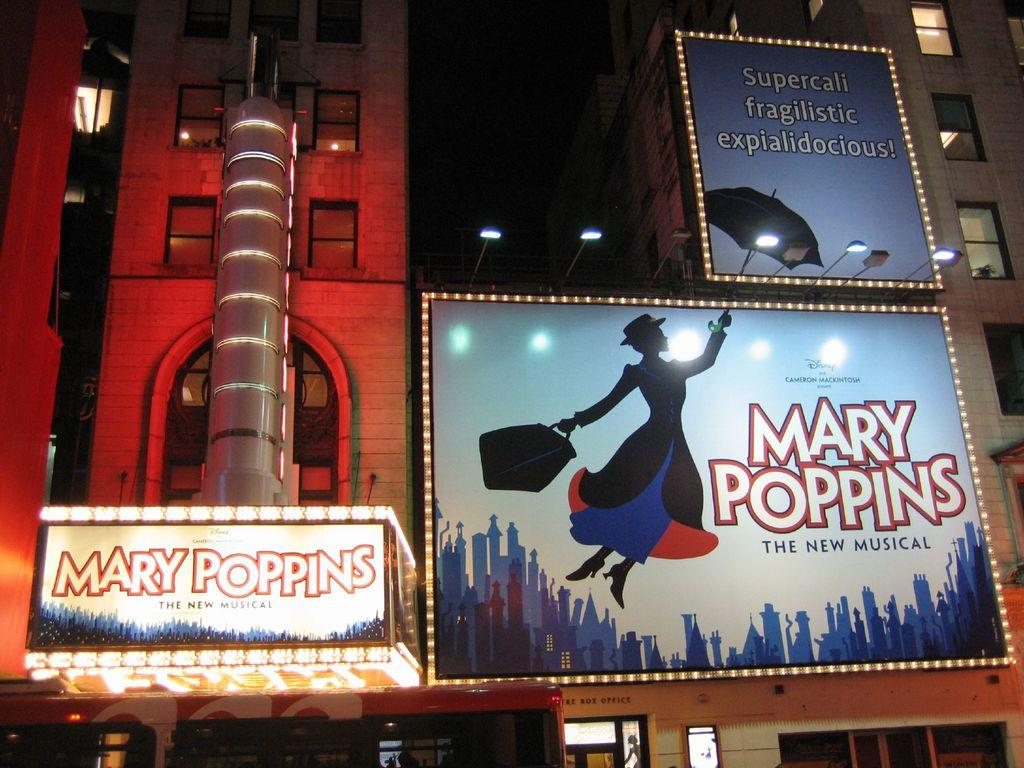<image>
Offer a succinct explanation of the picture presented. Outdoor lit up billboards with Mary Poppins on them. 